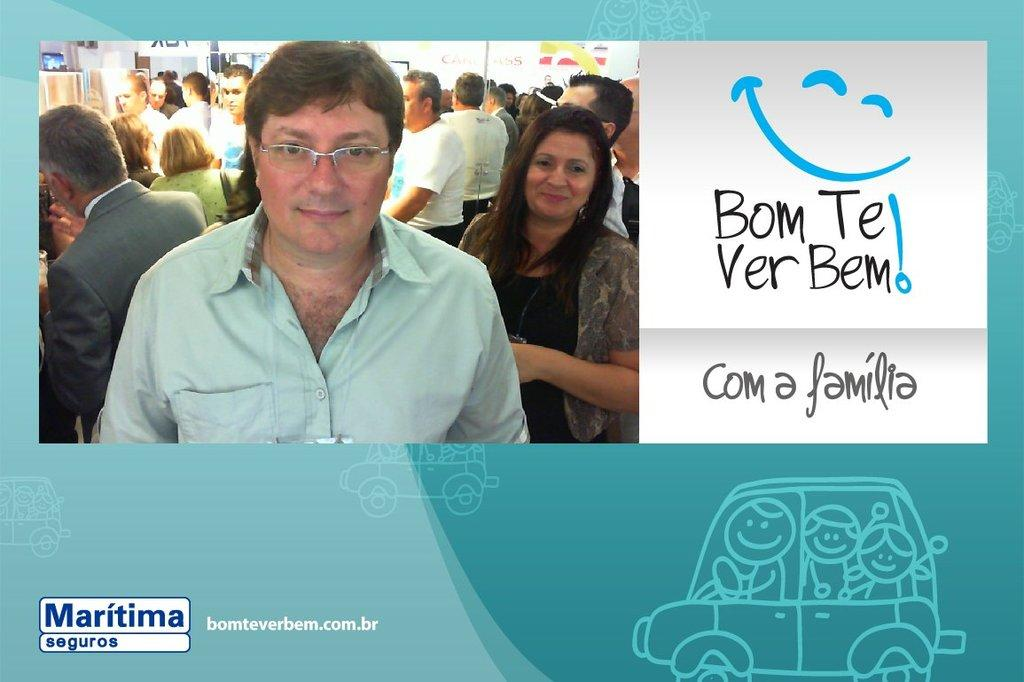What is featured in the image? There is a poster and a group of persons standing in the image. What are the persons in the image doing? The persons are standing and smiling. What is written or depicted on the poster? There are notes on the poster. What color is the background of the image? The background of the image is blue. Can you see anyone in the image using a gun? There is no gun present in the image. Is anyone in the image swimming? There is no swimming activity depicted in the image. 